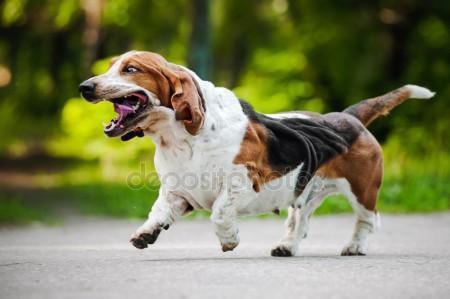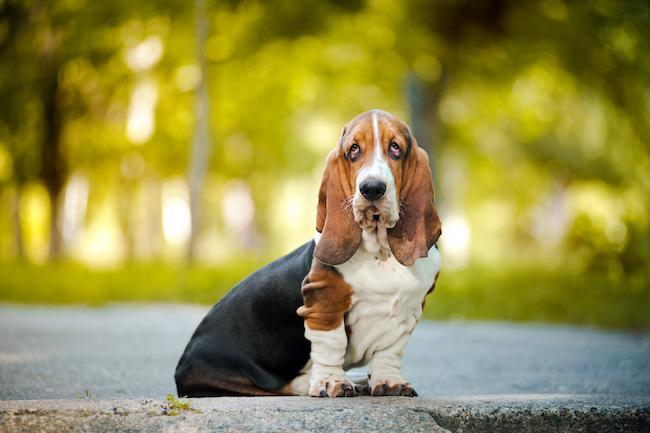The first image is the image on the left, the second image is the image on the right. Examine the images to the left and right. Is the description "In total, we have more than two dogs here." accurate? Answer yes or no. No. The first image is the image on the left, the second image is the image on the right. Considering the images on both sides, is "One of the image shows a single dog on a leash and the other shows a group of at least three dogs." valid? Answer yes or no. No. 